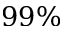Convert formula to latex. <formula><loc_0><loc_0><loc_500><loc_500>9 9 \%</formula> 